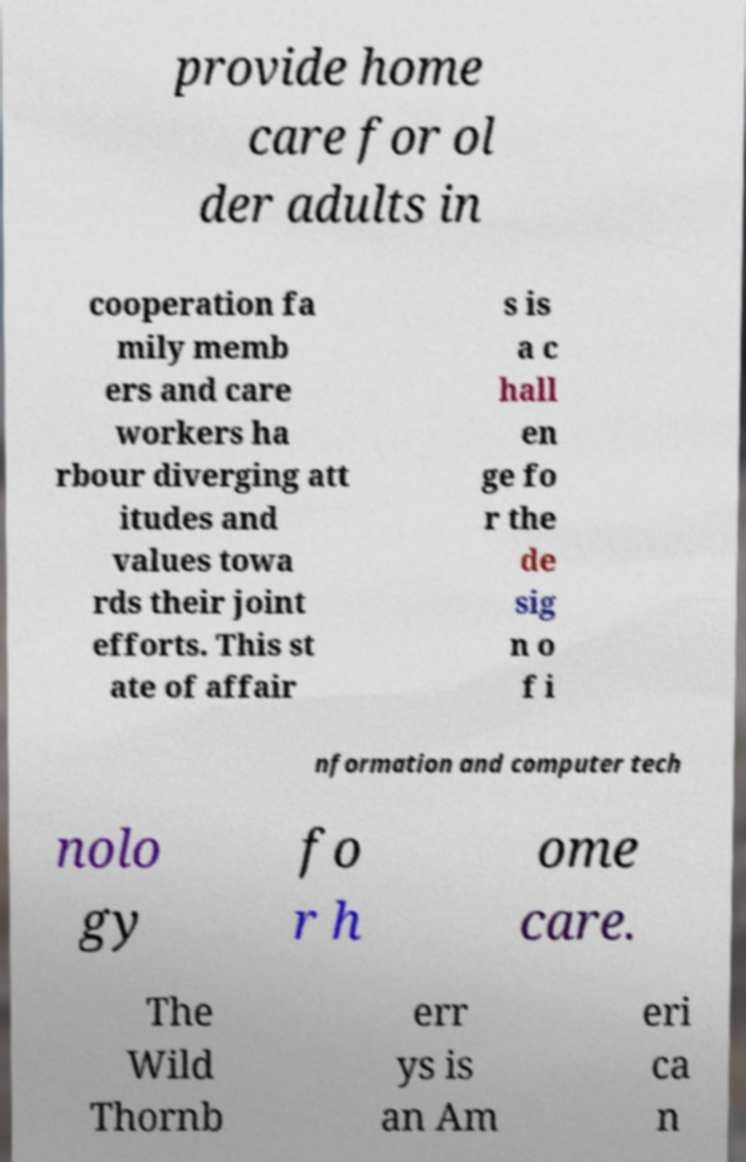Can you accurately transcribe the text from the provided image for me? provide home care for ol der adults in cooperation fa mily memb ers and care workers ha rbour diverging att itudes and values towa rds their joint efforts. This st ate of affair s is a c hall en ge fo r the de sig n o f i nformation and computer tech nolo gy fo r h ome care. The Wild Thornb err ys is an Am eri ca n 